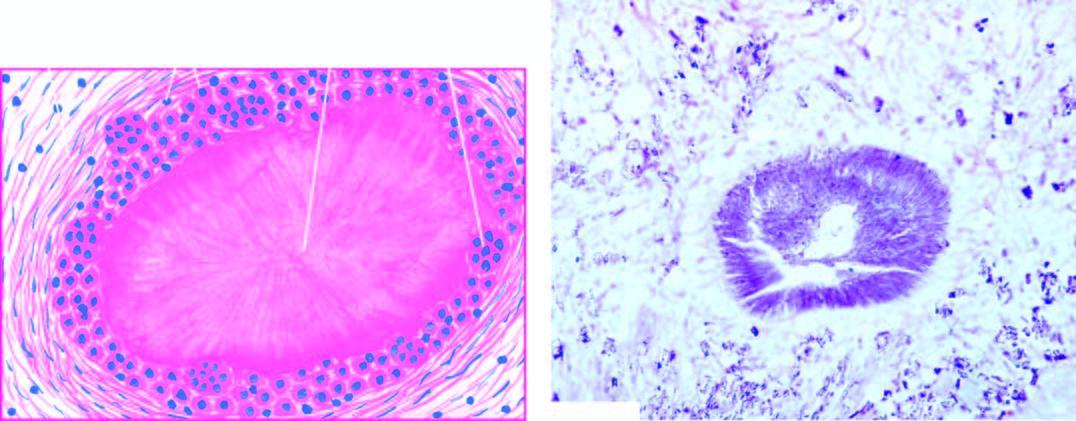how is gouty tophus, showing central aggregates of urate crystals surrounded?
Answer the question using a single word or phrase. By inflammatory cells 